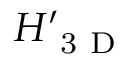Convert formula to latex. <formula><loc_0><loc_0><loc_500><loc_500>H _ { 3 D } ^ { \prime }</formula> 